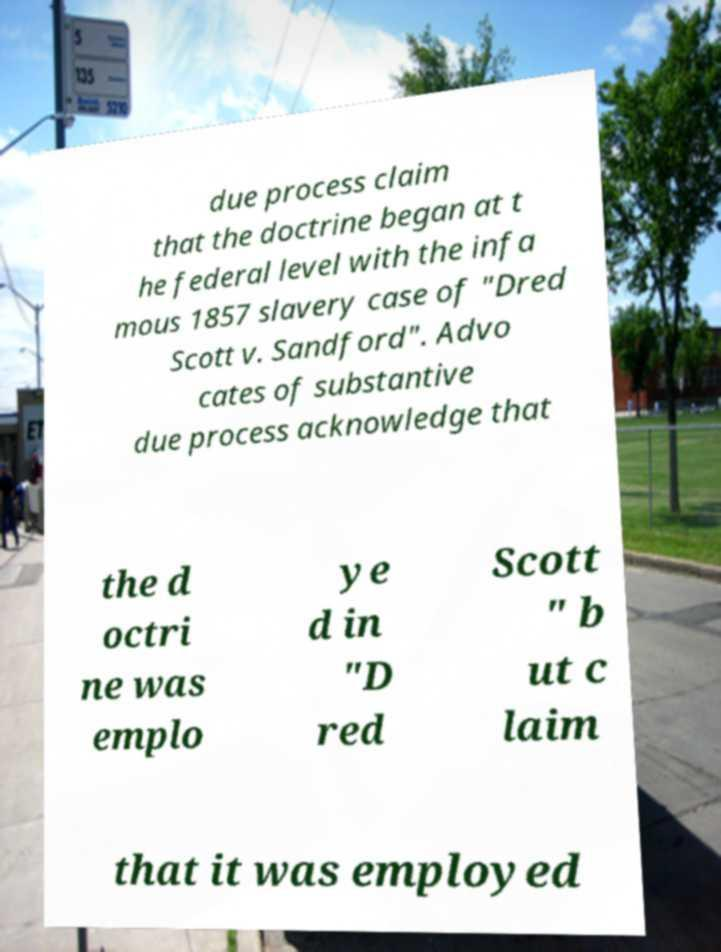There's text embedded in this image that I need extracted. Can you transcribe it verbatim? due process claim that the doctrine began at t he federal level with the infa mous 1857 slavery case of "Dred Scott v. Sandford". Advo cates of substantive due process acknowledge that the d octri ne was emplo ye d in "D red Scott " b ut c laim that it was employed 